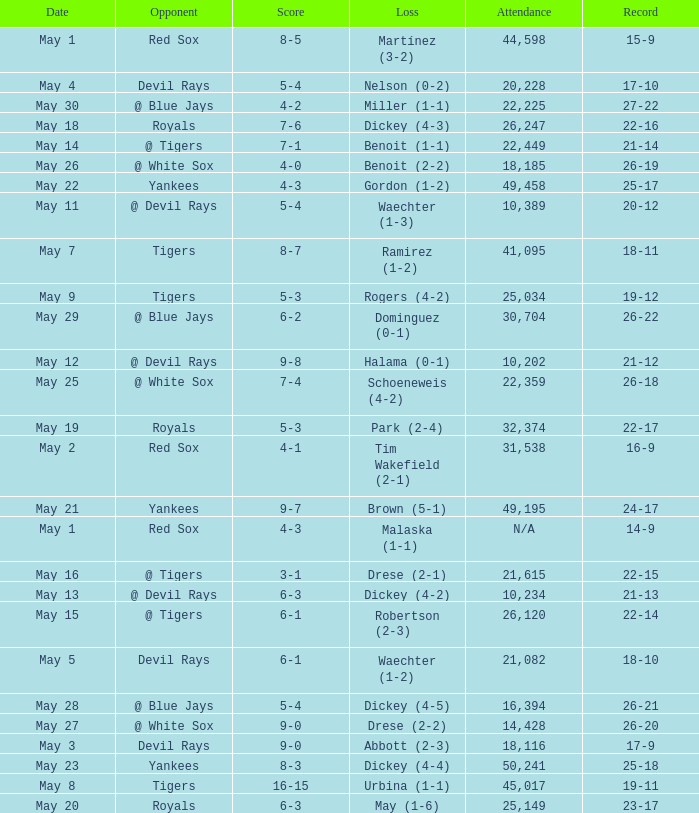What was the record at the game attended by 10,389? 20-12. Give me the full table as a dictionary. {'header': ['Date', 'Opponent', 'Score', 'Loss', 'Attendance', 'Record'], 'rows': [['May 1', 'Red Sox', '8-5', 'Martínez (3-2)', '44,598', '15-9'], ['May 4', 'Devil Rays', '5-4', 'Nelson (0-2)', '20,228', '17-10'], ['May 30', '@ Blue Jays', '4-2', 'Miller (1-1)', '22,225', '27-22'], ['May 18', 'Royals', '7-6', 'Dickey (4-3)', '26,247', '22-16'], ['May 14', '@ Tigers', '7-1', 'Benoit (1-1)', '22,449', '21-14'], ['May 26', '@ White Sox', '4-0', 'Benoit (2-2)', '18,185', '26-19'], ['May 22', 'Yankees', '4-3', 'Gordon (1-2)', '49,458', '25-17'], ['May 11', '@ Devil Rays', '5-4', 'Waechter (1-3)', '10,389', '20-12'], ['May 7', 'Tigers', '8-7', 'Ramirez (1-2)', '41,095', '18-11'], ['May 9', 'Tigers', '5-3', 'Rogers (4-2)', '25,034', '19-12'], ['May 29', '@ Blue Jays', '6-2', 'Dominguez (0-1)', '30,704', '26-22'], ['May 12', '@ Devil Rays', '9-8', 'Halama (0-1)', '10,202', '21-12'], ['May 25', '@ White Sox', '7-4', 'Schoeneweis (4-2)', '22,359', '26-18'], ['May 19', 'Royals', '5-3', 'Park (2-4)', '32,374', '22-17'], ['May 2', 'Red Sox', '4-1', 'Tim Wakefield (2-1)', '31,538', '16-9'], ['May 21', 'Yankees', '9-7', 'Brown (5-1)', '49,195', '24-17'], ['May 1', 'Red Sox', '4-3', 'Malaska (1-1)', 'N/A', '14-9'], ['May 16', '@ Tigers', '3-1', 'Drese (2-1)', '21,615', '22-15'], ['May 13', '@ Devil Rays', '6-3', 'Dickey (4-2)', '10,234', '21-13'], ['May 15', '@ Tigers', '6-1', 'Robertson (2-3)', '26,120', '22-14'], ['May 5', 'Devil Rays', '6-1', 'Waechter (1-2)', '21,082', '18-10'], ['May 28', '@ Blue Jays', '5-4', 'Dickey (4-5)', '16,394', '26-21'], ['May 27', '@ White Sox', '9-0', 'Drese (2-2)', '14,428', '26-20'], ['May 3', 'Devil Rays', '9-0', 'Abbott (2-3)', '18,116', '17-9'], ['May 23', 'Yankees', '8-3', 'Dickey (4-4)', '50,241', '25-18'], ['May 8', 'Tigers', '16-15', 'Urbina (1-1)', '45,017', '19-11'], ['May 20', 'Royals', '6-3', 'May (1-6)', '25,149', '23-17']]} 